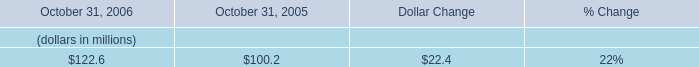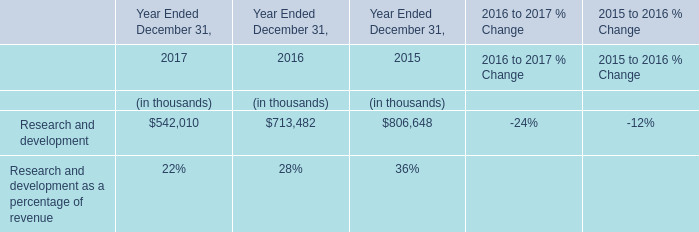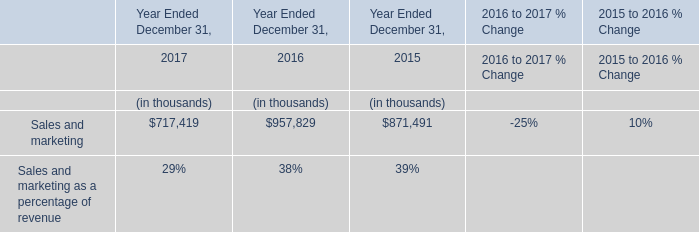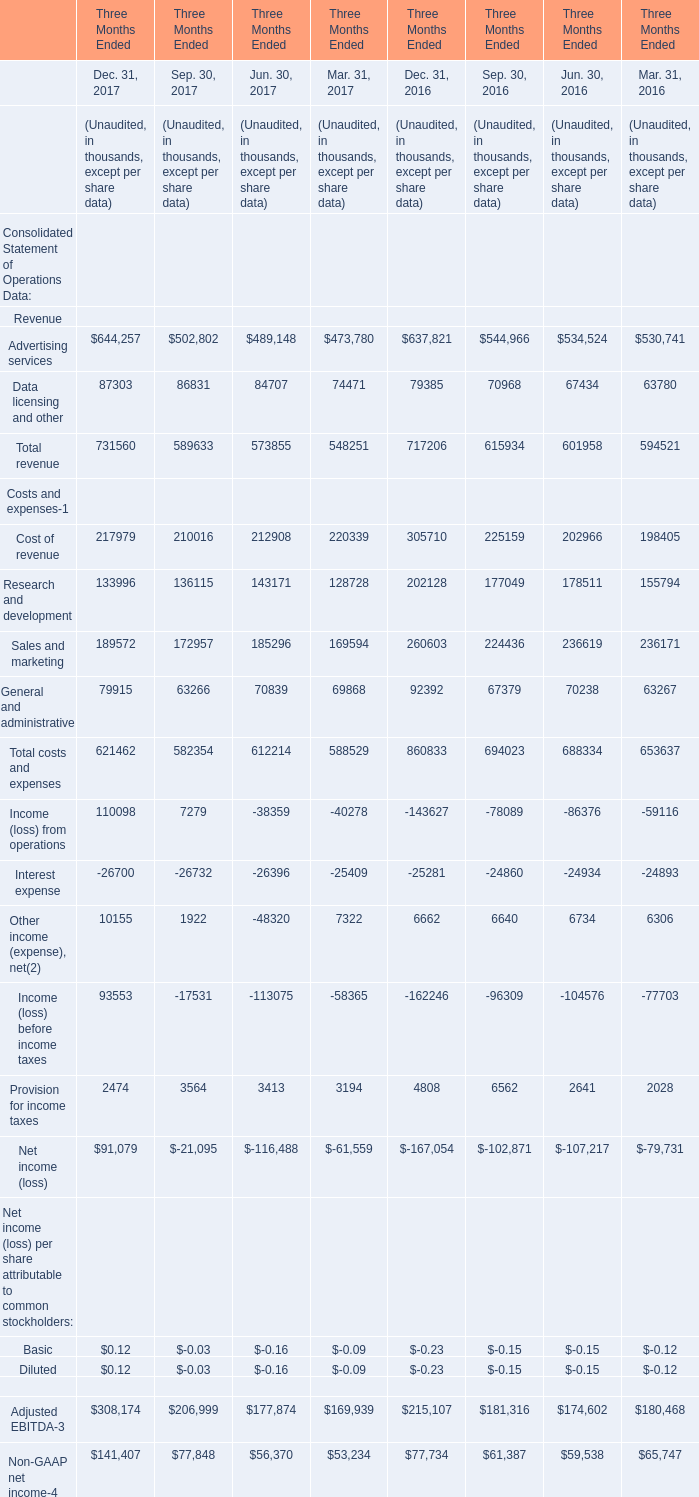considering the years 2005-2006 , what is the variation observed in the working capital , in millions? 
Computations: (130.6 - 23.4)
Answer: 107.2. 